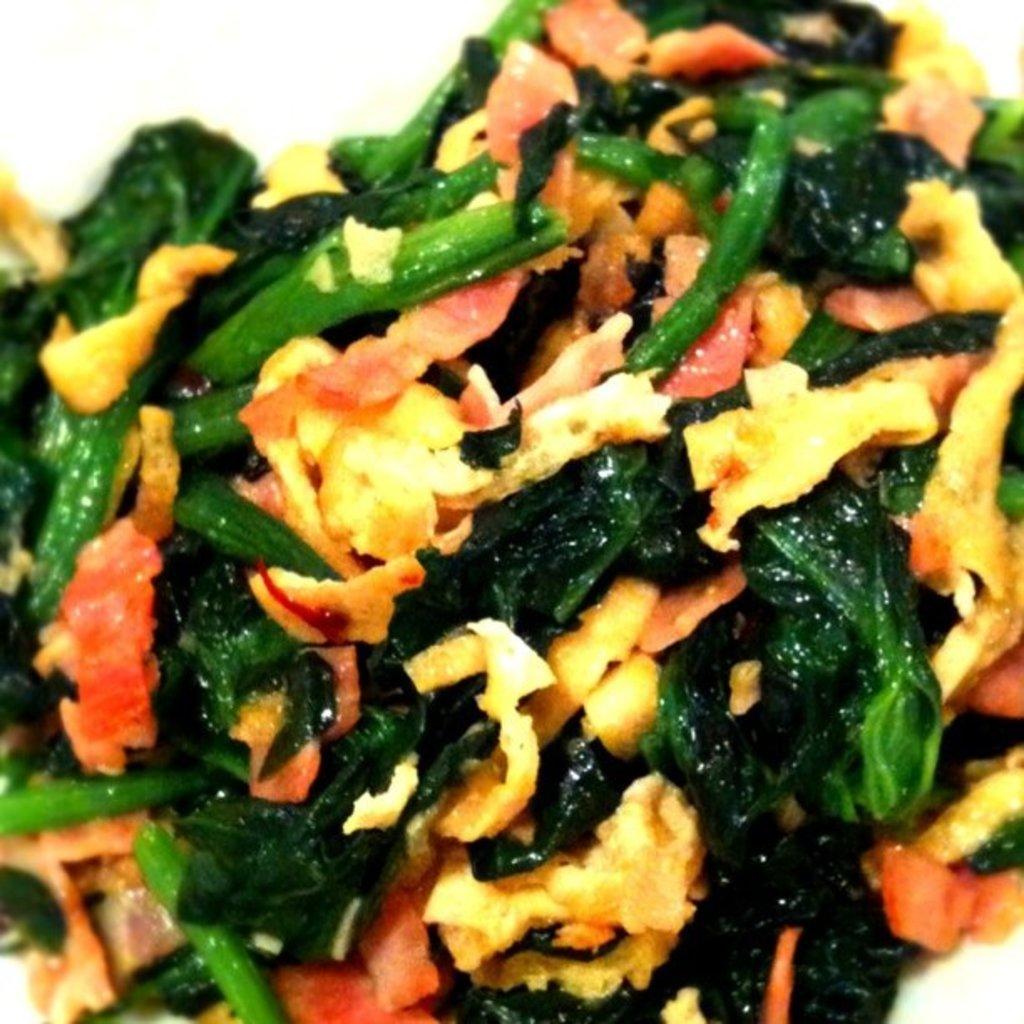Please provide a concise description of this image. There are vegetables pieces and other food items which are fried. And the background is white in color. 